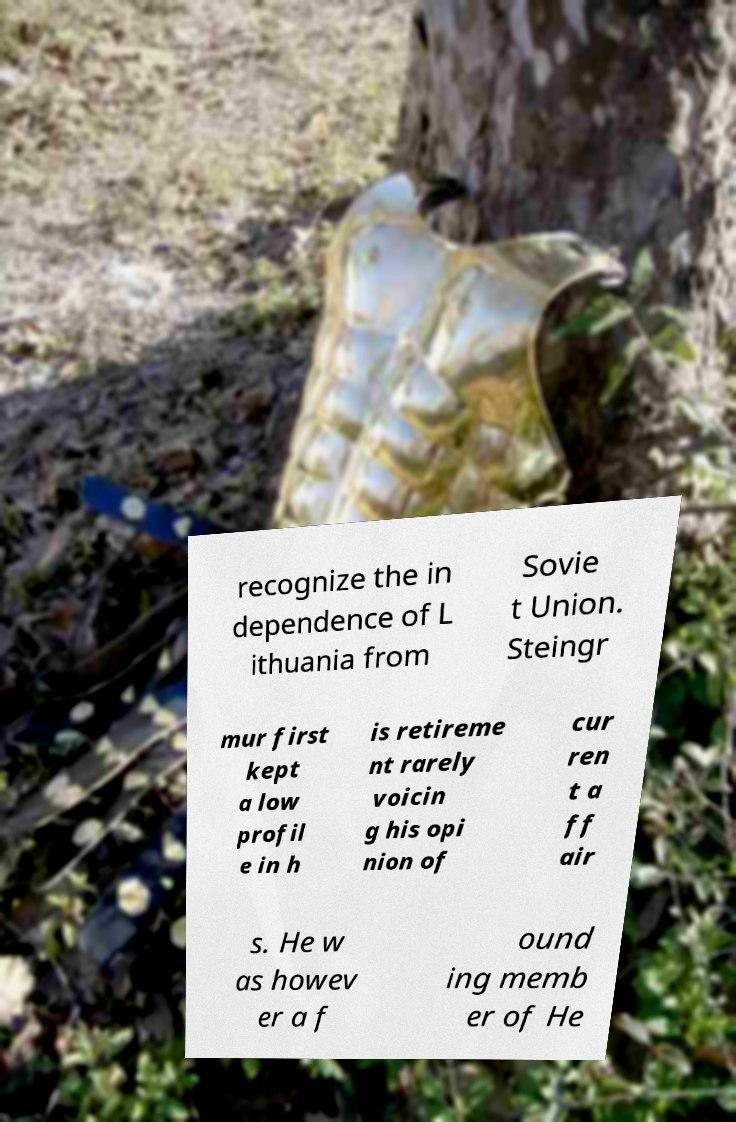There's text embedded in this image that I need extracted. Can you transcribe it verbatim? recognize the in dependence of L ithuania from Sovie t Union. Steingr mur first kept a low profil e in h is retireme nt rarely voicin g his opi nion of cur ren t a ff air s. He w as howev er a f ound ing memb er of He 